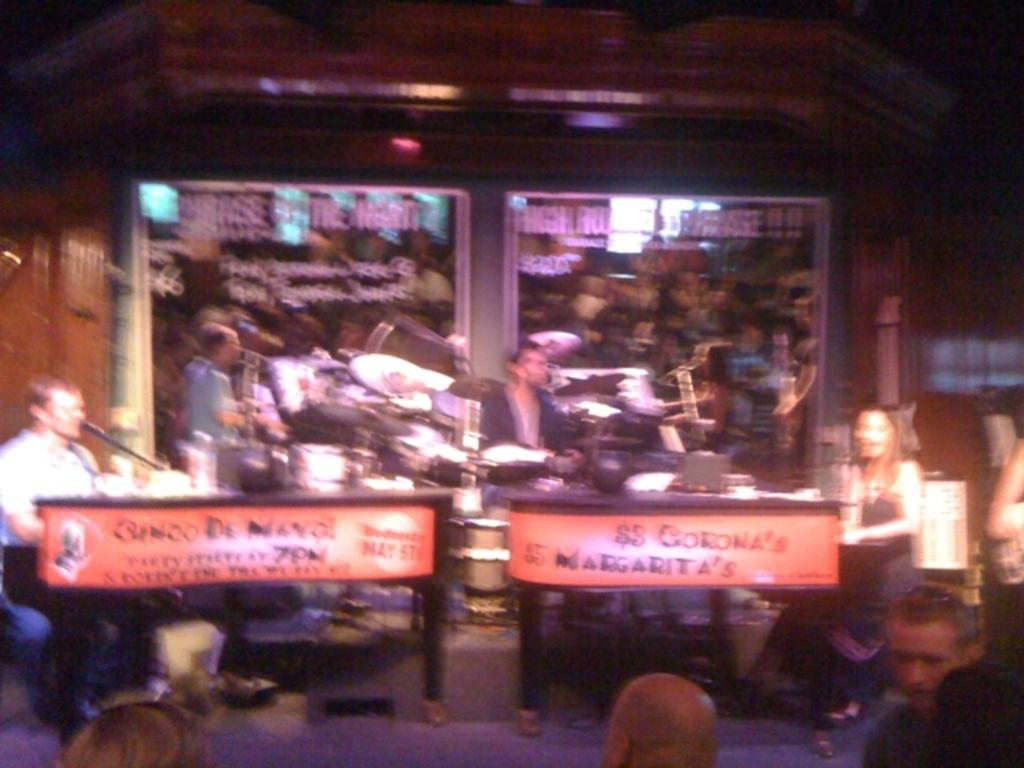What are the people in the image doing? The people in the image are sitting. What object is present for amplifying sound? There is a microphone in the image. What is providing illumination in the image? There is a light in the image. What surface is present for writing or displaying information? There is a board in the image. What can be seen in the background of the image? There is a glass and a wall in the background of the image. What time of day is it in the image, specifically in the afternoon? The time of day is not specified in the image, and there is no indication of the afternoon. Is there a fire visible in the image? No, there is no fire present in the image. 